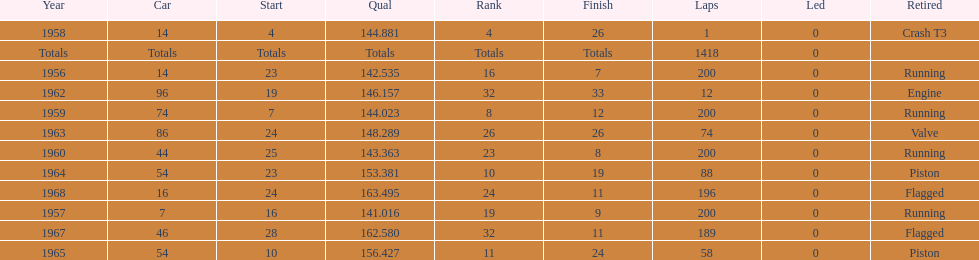What is the larger laps between 1963 or 1968 1968. 